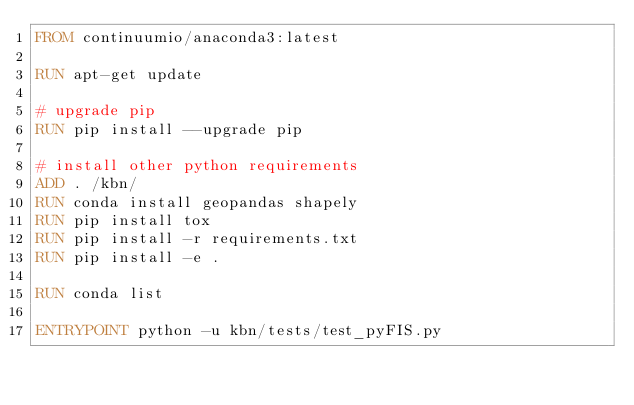Convert code to text. <code><loc_0><loc_0><loc_500><loc_500><_Dockerfile_>FROM continuumio/anaconda3:latest

RUN apt-get update

# upgrade pip
RUN pip install --upgrade pip

# install other python requirements
ADD . /kbn/
RUN conda install geopandas shapely
RUN pip install tox
RUN pip install -r requirements.txt
RUN pip install -e .

RUN conda list

ENTRYPOINT python -u kbn/tests/test_pyFIS.py
</code> 